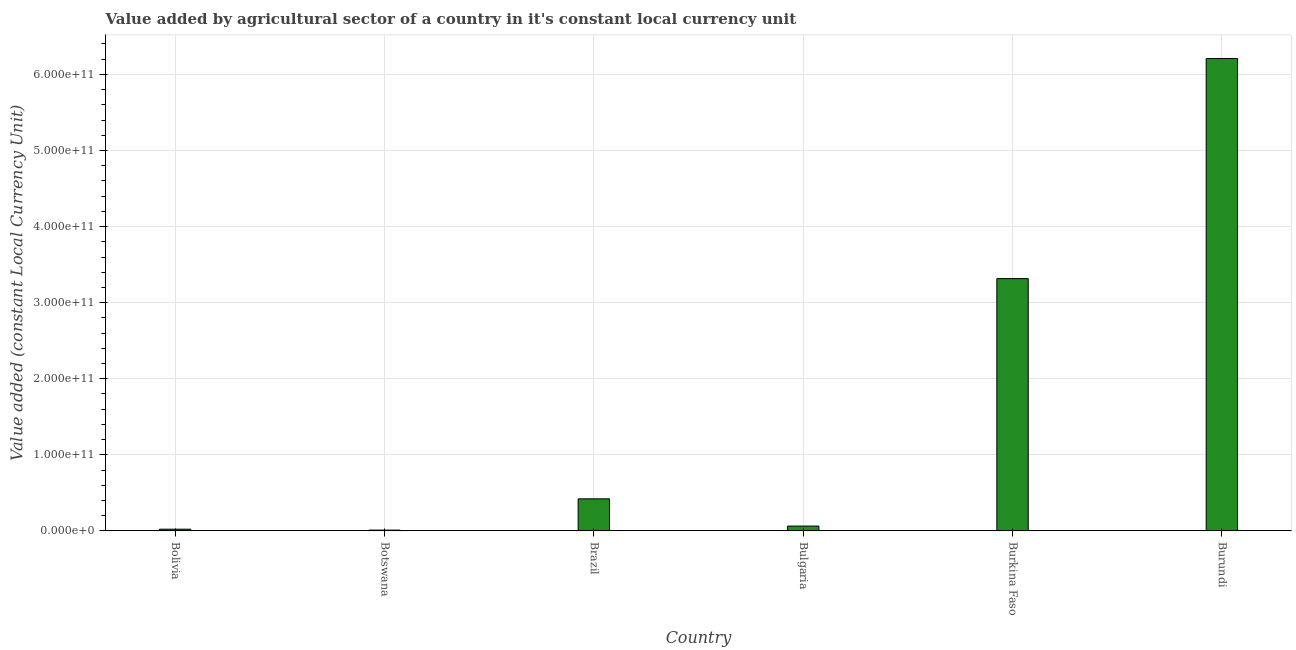Does the graph contain any zero values?
Your response must be concise. No. Does the graph contain grids?
Your response must be concise. Yes. What is the title of the graph?
Ensure brevity in your answer.  Value added by agricultural sector of a country in it's constant local currency unit. What is the label or title of the X-axis?
Your response must be concise. Country. What is the label or title of the Y-axis?
Keep it short and to the point. Value added (constant Local Currency Unit). What is the value added by agriculture sector in Burundi?
Offer a very short reply. 6.21e+11. Across all countries, what is the maximum value added by agriculture sector?
Provide a short and direct response. 6.21e+11. Across all countries, what is the minimum value added by agriculture sector?
Give a very brief answer. 1.07e+09. In which country was the value added by agriculture sector maximum?
Provide a short and direct response. Burundi. In which country was the value added by agriculture sector minimum?
Your answer should be compact. Botswana. What is the sum of the value added by agriculture sector?
Provide a succinct answer. 1.00e+12. What is the difference between the value added by agriculture sector in Botswana and Bulgaria?
Provide a short and direct response. -5.33e+09. What is the average value added by agriculture sector per country?
Your answer should be very brief. 1.67e+11. What is the median value added by agriculture sector?
Offer a very short reply. 2.43e+1. What is the ratio of the value added by agriculture sector in Botswana to that in Burundi?
Your answer should be very brief. 0. Is the value added by agriculture sector in Brazil less than that in Burkina Faso?
Provide a short and direct response. Yes. What is the difference between the highest and the second highest value added by agriculture sector?
Provide a succinct answer. 2.89e+11. Is the sum of the value added by agriculture sector in Botswana and Burkina Faso greater than the maximum value added by agriculture sector across all countries?
Give a very brief answer. No. What is the difference between the highest and the lowest value added by agriculture sector?
Provide a succinct answer. 6.20e+11. In how many countries, is the value added by agriculture sector greater than the average value added by agriculture sector taken over all countries?
Make the answer very short. 2. How many bars are there?
Provide a succinct answer. 6. Are all the bars in the graph horizontal?
Your response must be concise. No. What is the difference between two consecutive major ticks on the Y-axis?
Your answer should be compact. 1.00e+11. Are the values on the major ticks of Y-axis written in scientific E-notation?
Your answer should be compact. Yes. What is the Value added (constant Local Currency Unit) of Bolivia?
Your answer should be compact. 2.30e+09. What is the Value added (constant Local Currency Unit) in Botswana?
Offer a terse response. 1.07e+09. What is the Value added (constant Local Currency Unit) of Brazil?
Your answer should be very brief. 4.22e+1. What is the Value added (constant Local Currency Unit) in Bulgaria?
Provide a short and direct response. 6.40e+09. What is the Value added (constant Local Currency Unit) in Burkina Faso?
Your response must be concise. 3.32e+11. What is the Value added (constant Local Currency Unit) in Burundi?
Your response must be concise. 6.21e+11. What is the difference between the Value added (constant Local Currency Unit) in Bolivia and Botswana?
Keep it short and to the point. 1.23e+09. What is the difference between the Value added (constant Local Currency Unit) in Bolivia and Brazil?
Offer a very short reply. -3.99e+1. What is the difference between the Value added (constant Local Currency Unit) in Bolivia and Bulgaria?
Provide a short and direct response. -4.10e+09. What is the difference between the Value added (constant Local Currency Unit) in Bolivia and Burkina Faso?
Give a very brief answer. -3.29e+11. What is the difference between the Value added (constant Local Currency Unit) in Bolivia and Burundi?
Offer a very short reply. -6.19e+11. What is the difference between the Value added (constant Local Currency Unit) in Botswana and Brazil?
Your answer should be compact. -4.11e+1. What is the difference between the Value added (constant Local Currency Unit) in Botswana and Bulgaria?
Keep it short and to the point. -5.33e+09. What is the difference between the Value added (constant Local Currency Unit) in Botswana and Burkina Faso?
Your answer should be compact. -3.31e+11. What is the difference between the Value added (constant Local Currency Unit) in Botswana and Burundi?
Keep it short and to the point. -6.20e+11. What is the difference between the Value added (constant Local Currency Unit) in Brazil and Bulgaria?
Give a very brief answer. 3.58e+1. What is the difference between the Value added (constant Local Currency Unit) in Brazil and Burkina Faso?
Offer a very short reply. -2.89e+11. What is the difference between the Value added (constant Local Currency Unit) in Brazil and Burundi?
Give a very brief answer. -5.79e+11. What is the difference between the Value added (constant Local Currency Unit) in Bulgaria and Burkina Faso?
Ensure brevity in your answer.  -3.25e+11. What is the difference between the Value added (constant Local Currency Unit) in Bulgaria and Burundi?
Your answer should be compact. -6.14e+11. What is the difference between the Value added (constant Local Currency Unit) in Burkina Faso and Burundi?
Provide a short and direct response. -2.89e+11. What is the ratio of the Value added (constant Local Currency Unit) in Bolivia to that in Botswana?
Keep it short and to the point. 2.14. What is the ratio of the Value added (constant Local Currency Unit) in Bolivia to that in Brazil?
Make the answer very short. 0.06. What is the ratio of the Value added (constant Local Currency Unit) in Bolivia to that in Bulgaria?
Give a very brief answer. 0.36. What is the ratio of the Value added (constant Local Currency Unit) in Bolivia to that in Burkina Faso?
Your answer should be compact. 0.01. What is the ratio of the Value added (constant Local Currency Unit) in Bolivia to that in Burundi?
Your answer should be compact. 0. What is the ratio of the Value added (constant Local Currency Unit) in Botswana to that in Brazil?
Provide a short and direct response. 0.03. What is the ratio of the Value added (constant Local Currency Unit) in Botswana to that in Bulgaria?
Keep it short and to the point. 0.17. What is the ratio of the Value added (constant Local Currency Unit) in Botswana to that in Burkina Faso?
Keep it short and to the point. 0. What is the ratio of the Value added (constant Local Currency Unit) in Botswana to that in Burundi?
Provide a short and direct response. 0. What is the ratio of the Value added (constant Local Currency Unit) in Brazil to that in Bulgaria?
Provide a succinct answer. 6.59. What is the ratio of the Value added (constant Local Currency Unit) in Brazil to that in Burkina Faso?
Ensure brevity in your answer.  0.13. What is the ratio of the Value added (constant Local Currency Unit) in Brazil to that in Burundi?
Your response must be concise. 0.07. What is the ratio of the Value added (constant Local Currency Unit) in Bulgaria to that in Burkina Faso?
Make the answer very short. 0.02. What is the ratio of the Value added (constant Local Currency Unit) in Burkina Faso to that in Burundi?
Your response must be concise. 0.53. 